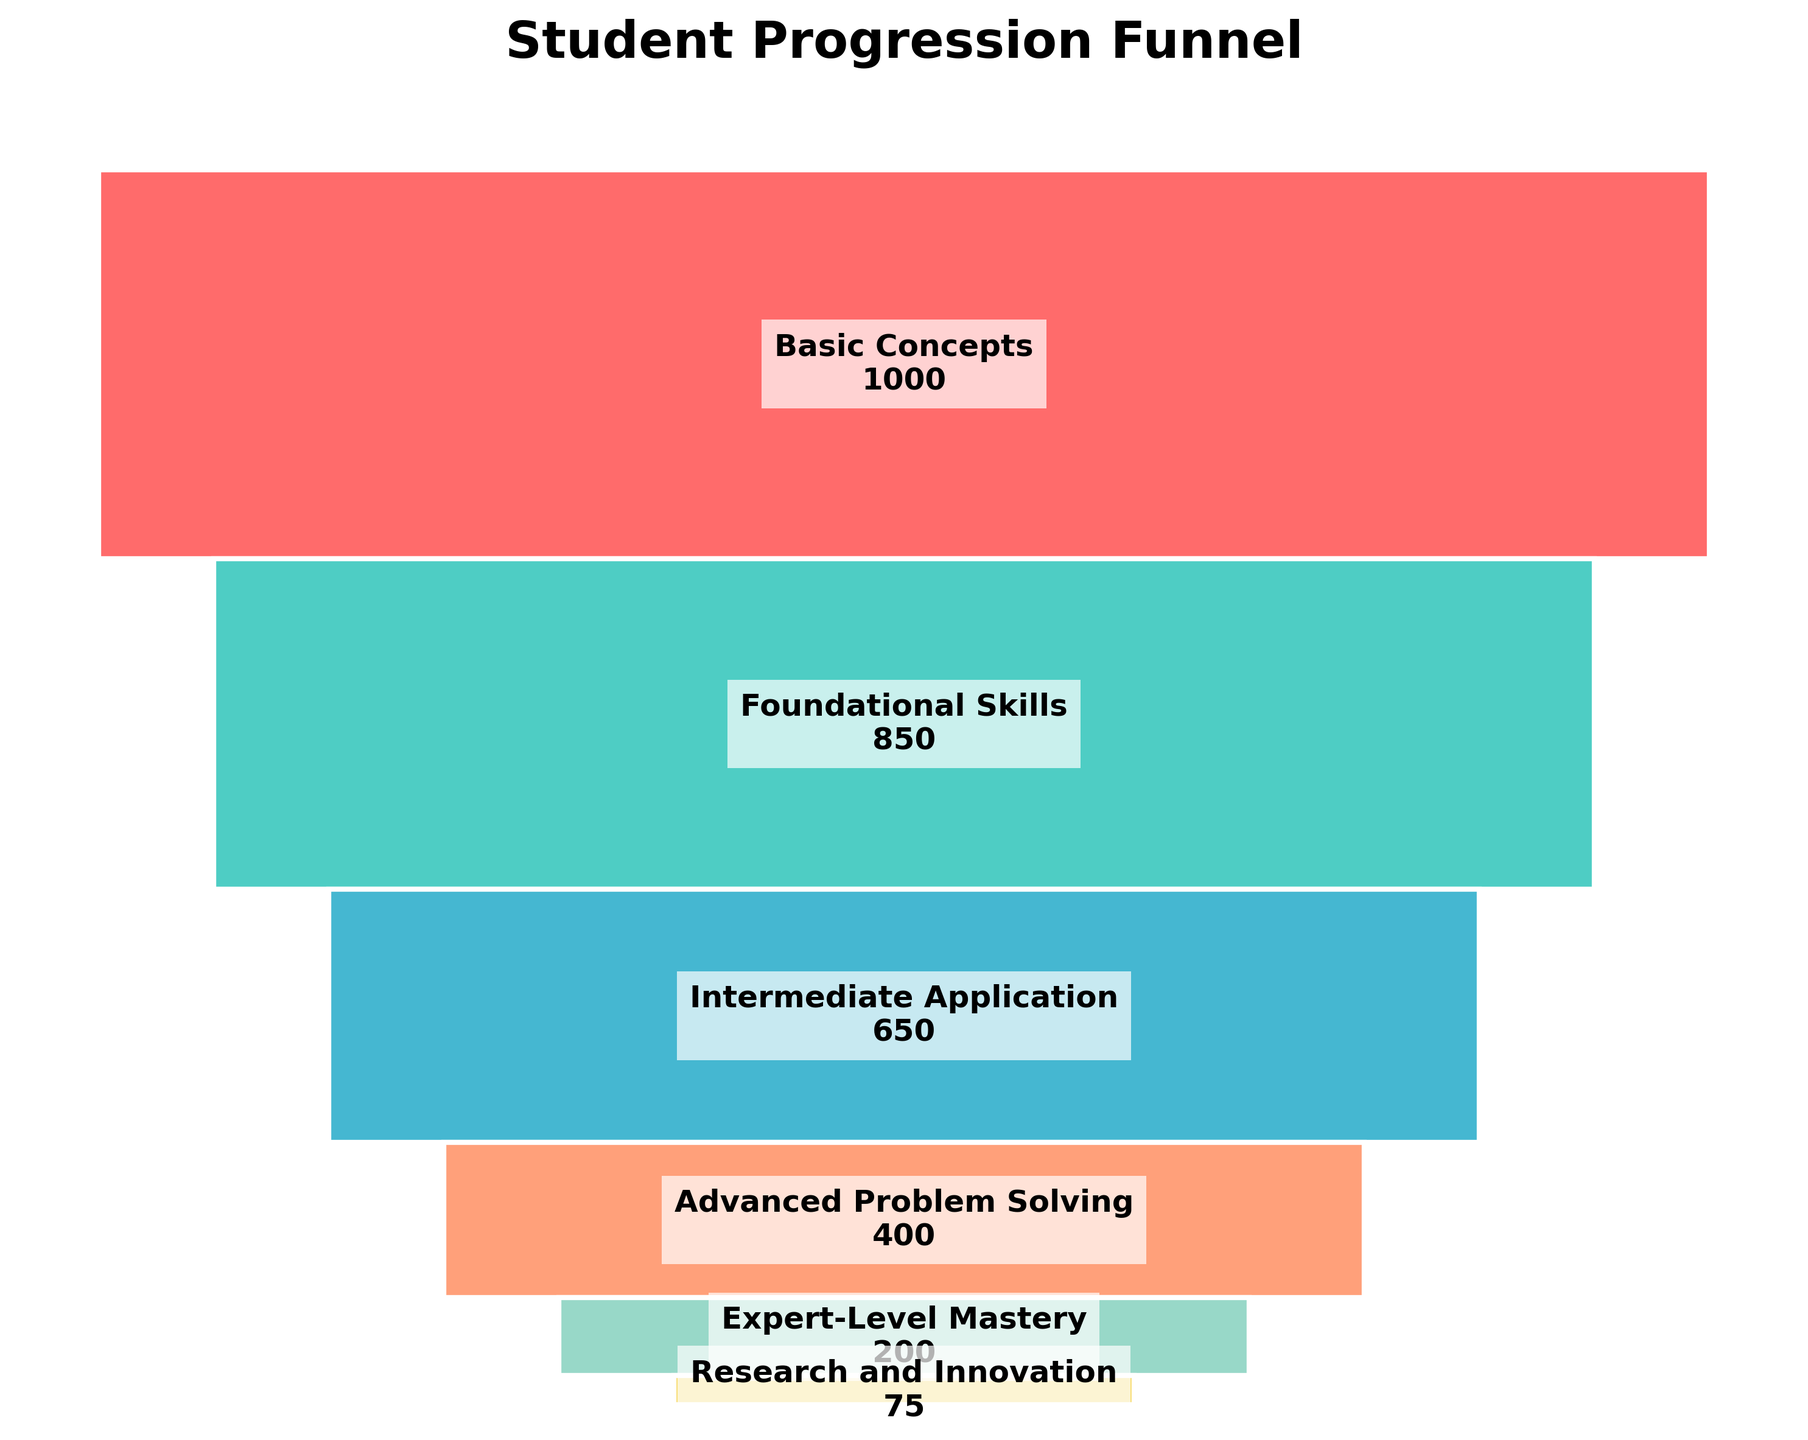What is the title of the chart? The title is typically displayed at the top of the chart and summarizes the main topic. In this case, the text "Student Progression Funnel" is clearly visible at the top of the funnel chart.
Answer: Student Progression Funnel How many stages are depicted in the funnel chart? By counting each individual stage listed in the funnel, we can determine the number of steps or levels in the progression. In this case, there are 6 stages listed.
Answer: 6 Which stage has the highest number of students? To determine the stage with the highest number of students, we compare the student numbers across all stages. The stage with the largest value, 1000, corresponds to "Basic Concepts."
Answer: Basic Concepts What is the difference in the number of students between the "Intermediate Application" and "Advanced Problem Solving" stages? First, identify the student counts for both stages: "Intermediate Application" has 650 students and "Advanced Problem Solving" has 400. Subtract the smaller number from the larger number: 650 - 400 = 250.
Answer: 250 How many students are there in the final stage, "Research and Innovation"? To find this value, look at the student number associated with the "Research and Innovation" stage. The chart indicates that there are 75 students in this final stage.
Answer: 75 What is the total number of students in the "Intermediate Application" and "Expert-Level Mastery" stages together? Add the number of students in the "Intermediate Application" stage (650) to the number of students in the "Expert-Level Mastery" stage (200): 650 + 200 = 850.
Answer: 850 Which stage sees the largest drop in the number of students when compared to the previous stage? To determine this, calculate the drop in student numbers between consecutive stages and identify the largest drop. The biggest drop is between "Foundational Skills" (850) and "Intermediate Application" (650), which is 850 - 650 = 200.
Answer: Foundational Skills to Intermediate Application How many more students are there at the "Basic Concepts" stage compared to the "Expert-Level Mastery" stage? Calculate the difference between the number of students at the "Basic Concepts" stage (1000) and the "Expert-Level Mastery" stage (200): 1000 - 200 = 800.
Answer: 800 Why is the width of the bar at each stage decreasing as we move down the funnel chart? In a funnel chart, the width of each bar generally represents the proportion of the total number of students at each stage. As fewer students progress to the more advanced stages, the bars become narrower to visually indicate this reduction in numbers.
Answer: Represents decreasing number of students Between which two consecutive stages is the smallest decrease in the number of students? Compare the decreases between each pair of consecutive stages to find the smallest difference. The smallest decrease is between "Intermediate Application" (650) and "Advanced Problem Solving" (400), which is 650 - 400 = 250.
Answer: Intermediate Application to Advanced Problem Solving 